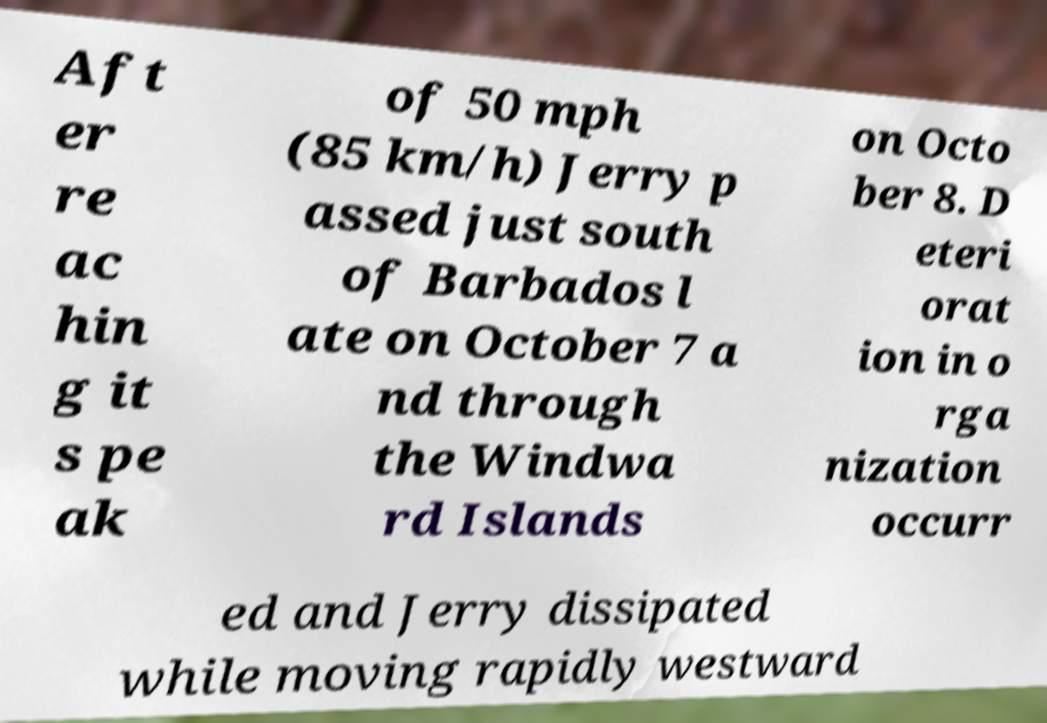I need the written content from this picture converted into text. Can you do that? Aft er re ac hin g it s pe ak of 50 mph (85 km/h) Jerry p assed just south of Barbados l ate on October 7 a nd through the Windwa rd Islands on Octo ber 8. D eteri orat ion in o rga nization occurr ed and Jerry dissipated while moving rapidly westward 